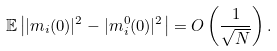Convert formula to latex. <formula><loc_0><loc_0><loc_500><loc_500>\mathbb { E } \left | | m _ { i } ( 0 ) | ^ { 2 } - | m ^ { 0 } _ { i } ( 0 ) | ^ { 2 } \right | = O \left ( \frac { 1 } { \sqrt { N } } \right ) .</formula> 